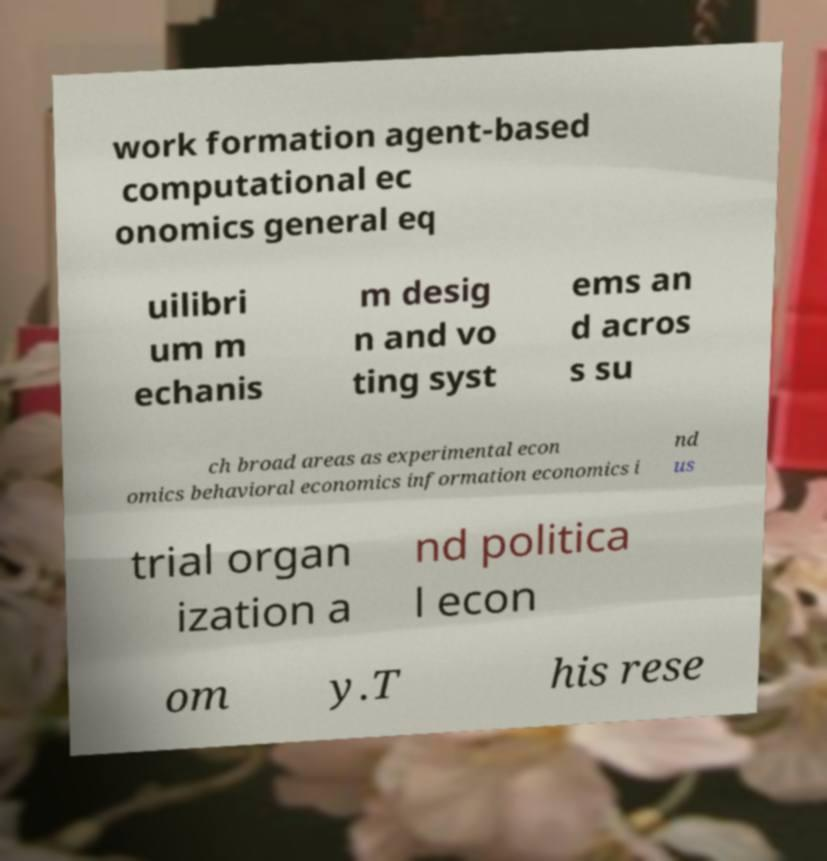Please read and relay the text visible in this image. What does it say? work formation agent-based computational ec onomics general eq uilibri um m echanis m desig n and vo ting syst ems an d acros s su ch broad areas as experimental econ omics behavioral economics information economics i nd us trial organ ization a nd politica l econ om y.T his rese 